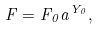<formula> <loc_0><loc_0><loc_500><loc_500>F = F _ { 0 } a ^ { Y _ { 0 } } ,</formula> 